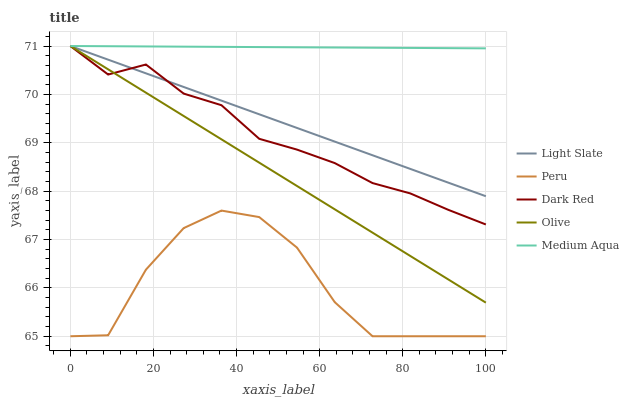Does Peru have the minimum area under the curve?
Answer yes or no. Yes. Does Medium Aqua have the maximum area under the curve?
Answer yes or no. Yes. Does Dark Red have the minimum area under the curve?
Answer yes or no. No. Does Dark Red have the maximum area under the curve?
Answer yes or no. No. Is Olive the smoothest?
Answer yes or no. Yes. Is Peru the roughest?
Answer yes or no. Yes. Is Dark Red the smoothest?
Answer yes or no. No. Is Dark Red the roughest?
Answer yes or no. No. Does Peru have the lowest value?
Answer yes or no. Yes. Does Dark Red have the lowest value?
Answer yes or no. No. Does Olive have the highest value?
Answer yes or no. Yes. Does Peru have the highest value?
Answer yes or no. No. Is Peru less than Dark Red?
Answer yes or no. Yes. Is Light Slate greater than Peru?
Answer yes or no. Yes. Does Dark Red intersect Olive?
Answer yes or no. Yes. Is Dark Red less than Olive?
Answer yes or no. No. Is Dark Red greater than Olive?
Answer yes or no. No. Does Peru intersect Dark Red?
Answer yes or no. No. 